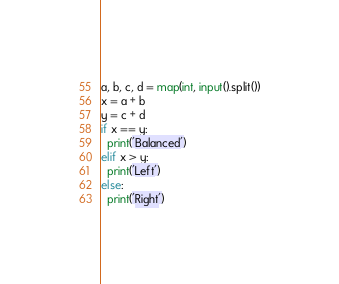<code> <loc_0><loc_0><loc_500><loc_500><_Python_>a, b, c, d = map(int, input().split())
x = a + b
y = c + d
if x == y:
  print('Balanced')
elif x > y:
  print('Left')
else:
  print('Right')</code> 